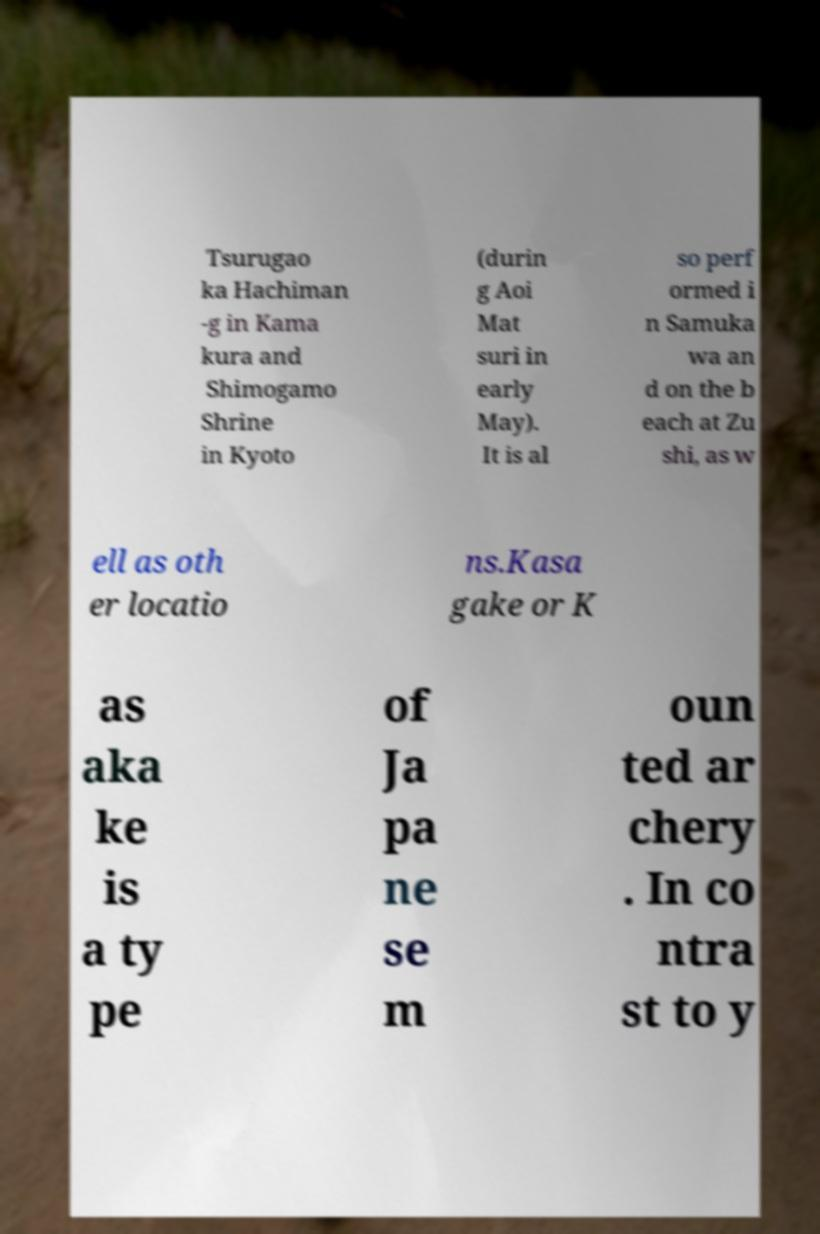Could you extract and type out the text from this image? Tsurugao ka Hachiman -g in Kama kura and Shimogamo Shrine in Kyoto (durin g Aoi Mat suri in early May). It is al so perf ormed i n Samuka wa an d on the b each at Zu shi, as w ell as oth er locatio ns.Kasa gake or K as aka ke is a ty pe of Ja pa ne se m oun ted ar chery . In co ntra st to y 